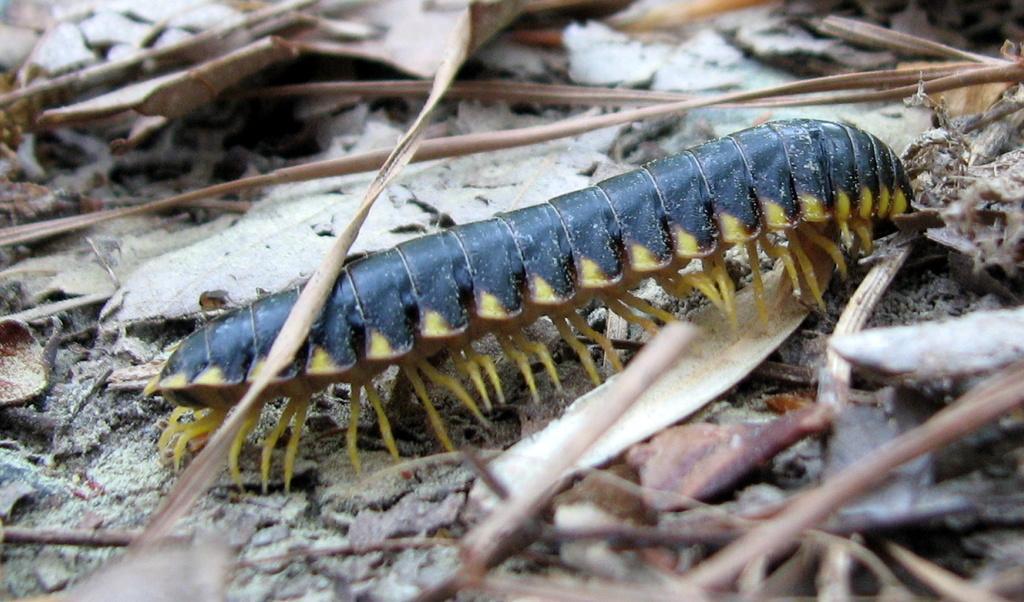Describe this image in one or two sentences. In this picture we can see an insect on the ground and in the background we can see dried leaves. 